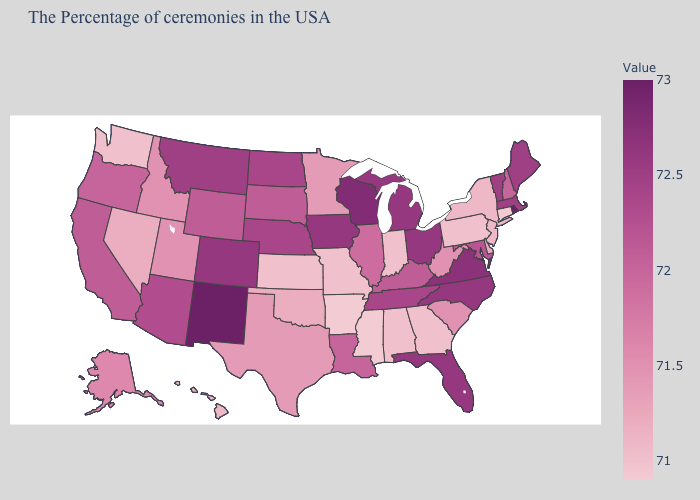Among the states that border Mississippi , does Arkansas have the lowest value?
Concise answer only. Yes. Which states hav the highest value in the West?
Keep it brief. New Mexico. Which states hav the highest value in the South?
Quick response, please. Virginia. Is the legend a continuous bar?
Be succinct. Yes. Does Wyoming have a lower value than Tennessee?
Give a very brief answer. Yes. Which states hav the highest value in the West?
Write a very short answer. New Mexico. Among the states that border Mississippi , which have the highest value?
Short answer required. Tennessee. Which states have the lowest value in the USA?
Concise answer only. Connecticut, Mississippi, Arkansas. 